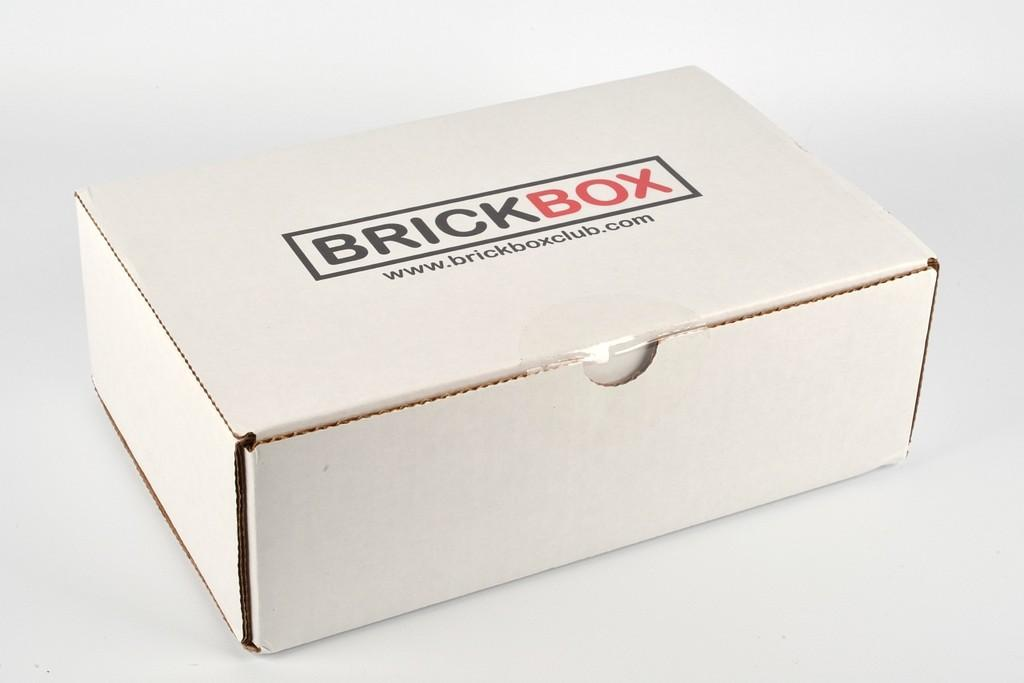<image>
Write a terse but informative summary of the picture. A small white closed box from the company Brick Box is on a white surface. 